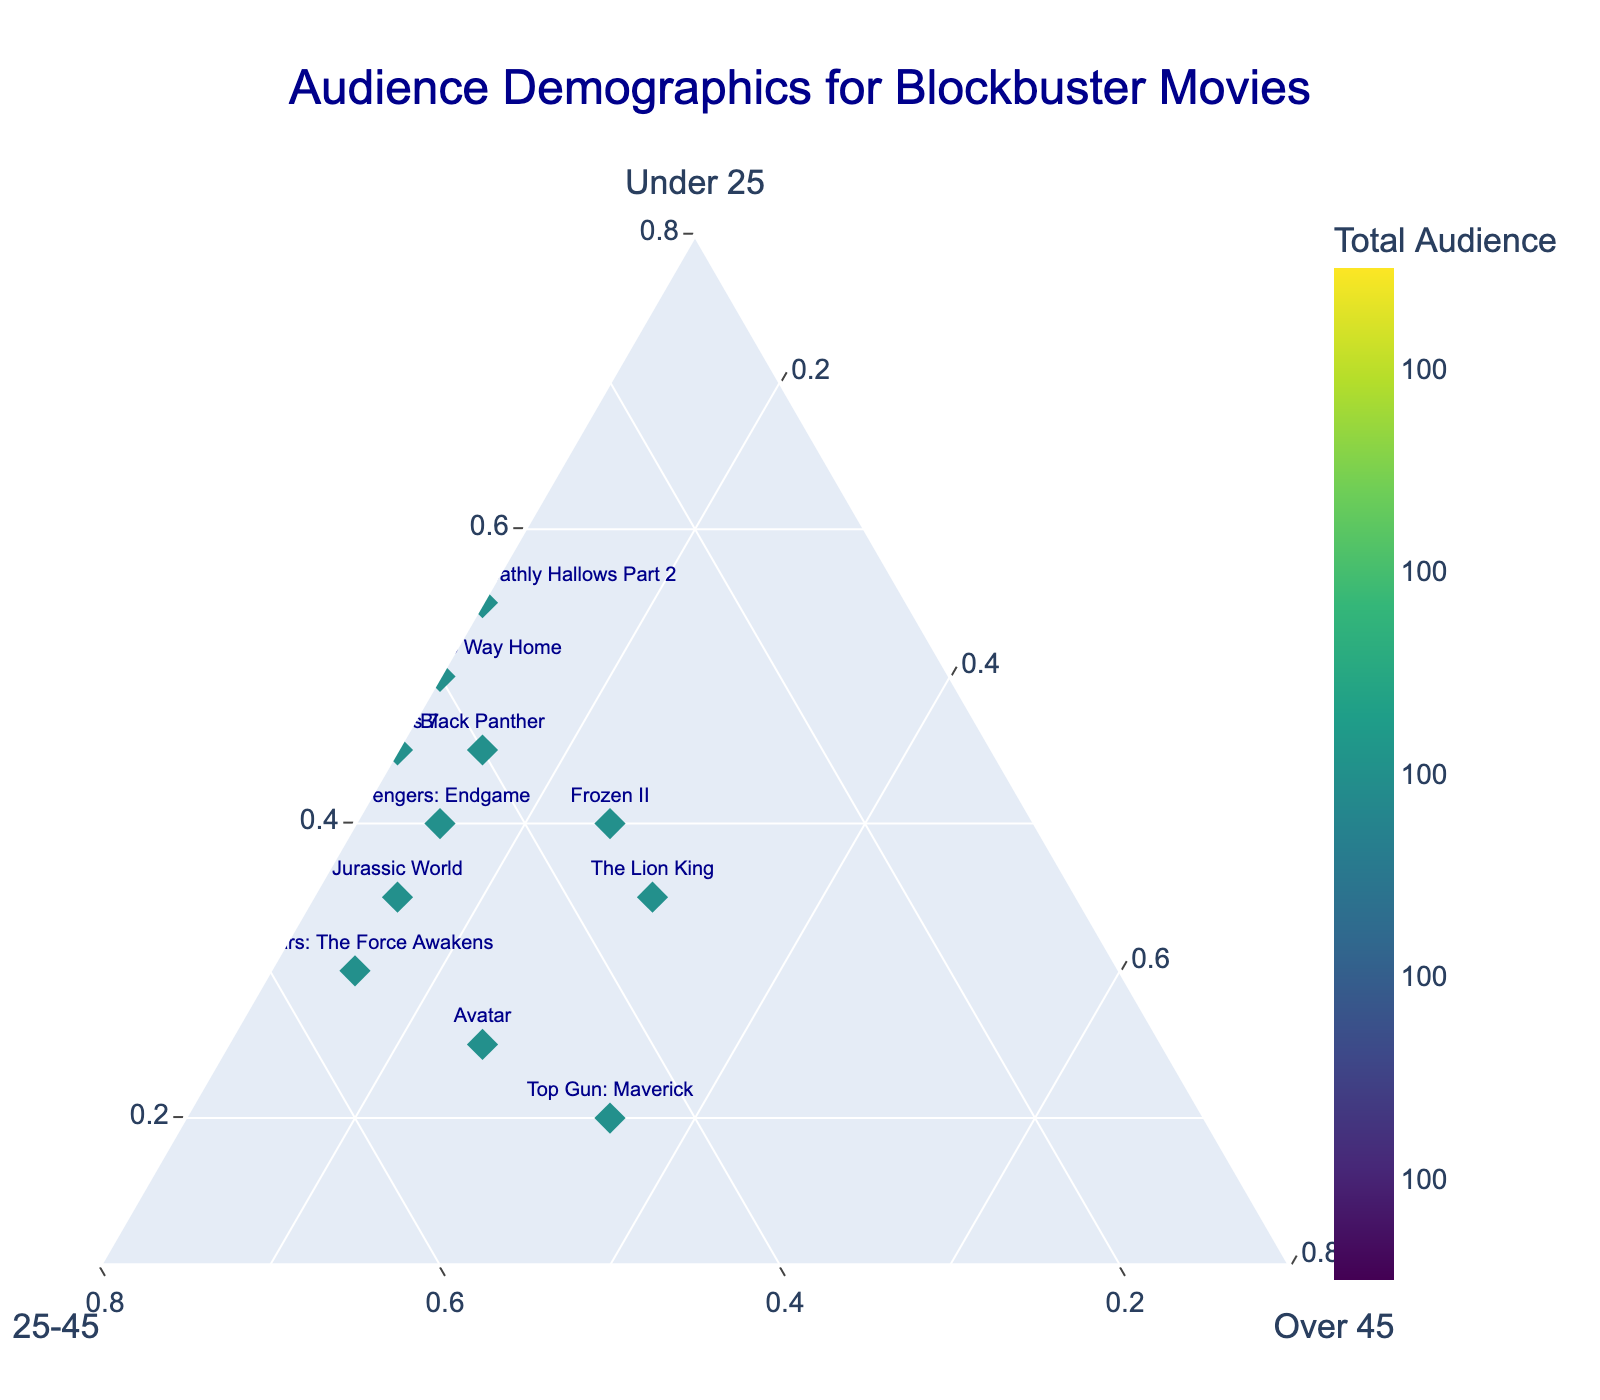What's the title of the Ternary Plot? The title of the Ternary Plot is located prominently at the top of the figure and includes a brief description of what the plot shows.
Answer: Audience Demographics for Blockbuster Movies How many movies are represented in the plot? To find the number of movies, count the data points in the plot. Each point is labeled with a movie name, and there are 11 labeled points.
Answer: 11 Which movie has the highest percentage of audience under 25? Identify the point that is closest to the 'Under 25' axis. The point for 'Harry Potter and the Deathly Hallows Part 2' is closest to this axis.
Answer: Harry Potter and the Deathly Hallows Part 2 Which movie has the largest overall audience, according to the color scale? The color scale indicates the total audience size, with darker colors representing larger audiences. Locate the movie point with the darkest color, which is 'Harry Potter and the Deathly Hallows Part 2'.
Answer: Harry Potter and the Deathly Hallows Part 2 What is the approximate percentage of audience aged 25-45 for 'Frozen II'? Read the position of 'Frozen II' relative to the '25-45' axis. 'Frozen II' is positioned around the 35% mark on the '25-45' axis.
Answer: 35% Which movie has the most balanced audience distribution among the three age groups? Look for the data point that is closest to the center of the ternary plot, indicating a similar proportion among all three age groups. This point is for 'The Lion King'.
Answer: The Lion King If we combine the audience groups of 'Under 25' and '25-45', which movie has the largest combined percentage? Sum the 'Under 25' and '25-45' percentages for all movies and identify the highest total. 'Harry Potter and the Deathly Hallows Part 2' has a total of 55% + 35% = 90%.
Answer: Harry Potter and the Deathly Hallows Part 2 Which movie has the highest percentage of audience over 45, and what is that percentage? Locate the point closest to the 'Over 45' axis. 'Top Gun: Maverick' is closest, with about 35% over 45 viewers.
Answer: Top Gun: Maverick, 35% Which two movies have the same percentage of audience over 45? Examine the plot to find points that share the same position along the 'Over 45' axis. Both 'Avengers: Endgame' and 'Jurassic World' have 15% of their audience in this group.
Answer: Avengers: Endgame and Jurassic World How does the audience distribution of 'Black Panther' compare to 'Spider-Man: No Way Home' in terms of the 'Under 25' group? Compare the positions of 'Black Panther' and 'Spider-Man: No Way Home' along the 'Under 25' axis. 'Black Panther' has 45% and 'Spider-Man: No Way Home' has 50%.
Answer: Spider-Man: No Way Home has a higher percentage of Under 25 viewers than Black Panther 